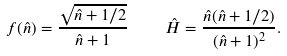Convert formula to latex. <formula><loc_0><loc_0><loc_500><loc_500>f ( \hat { n } ) = \frac { \sqrt { \hat { n } + 1 / 2 } } { \hat { n } + 1 } \quad \hat { H } = \frac { \hat { n } ( \hat { n } + 1 / 2 ) } { ( \hat { n } + 1 ) ^ { 2 } } .</formula> 